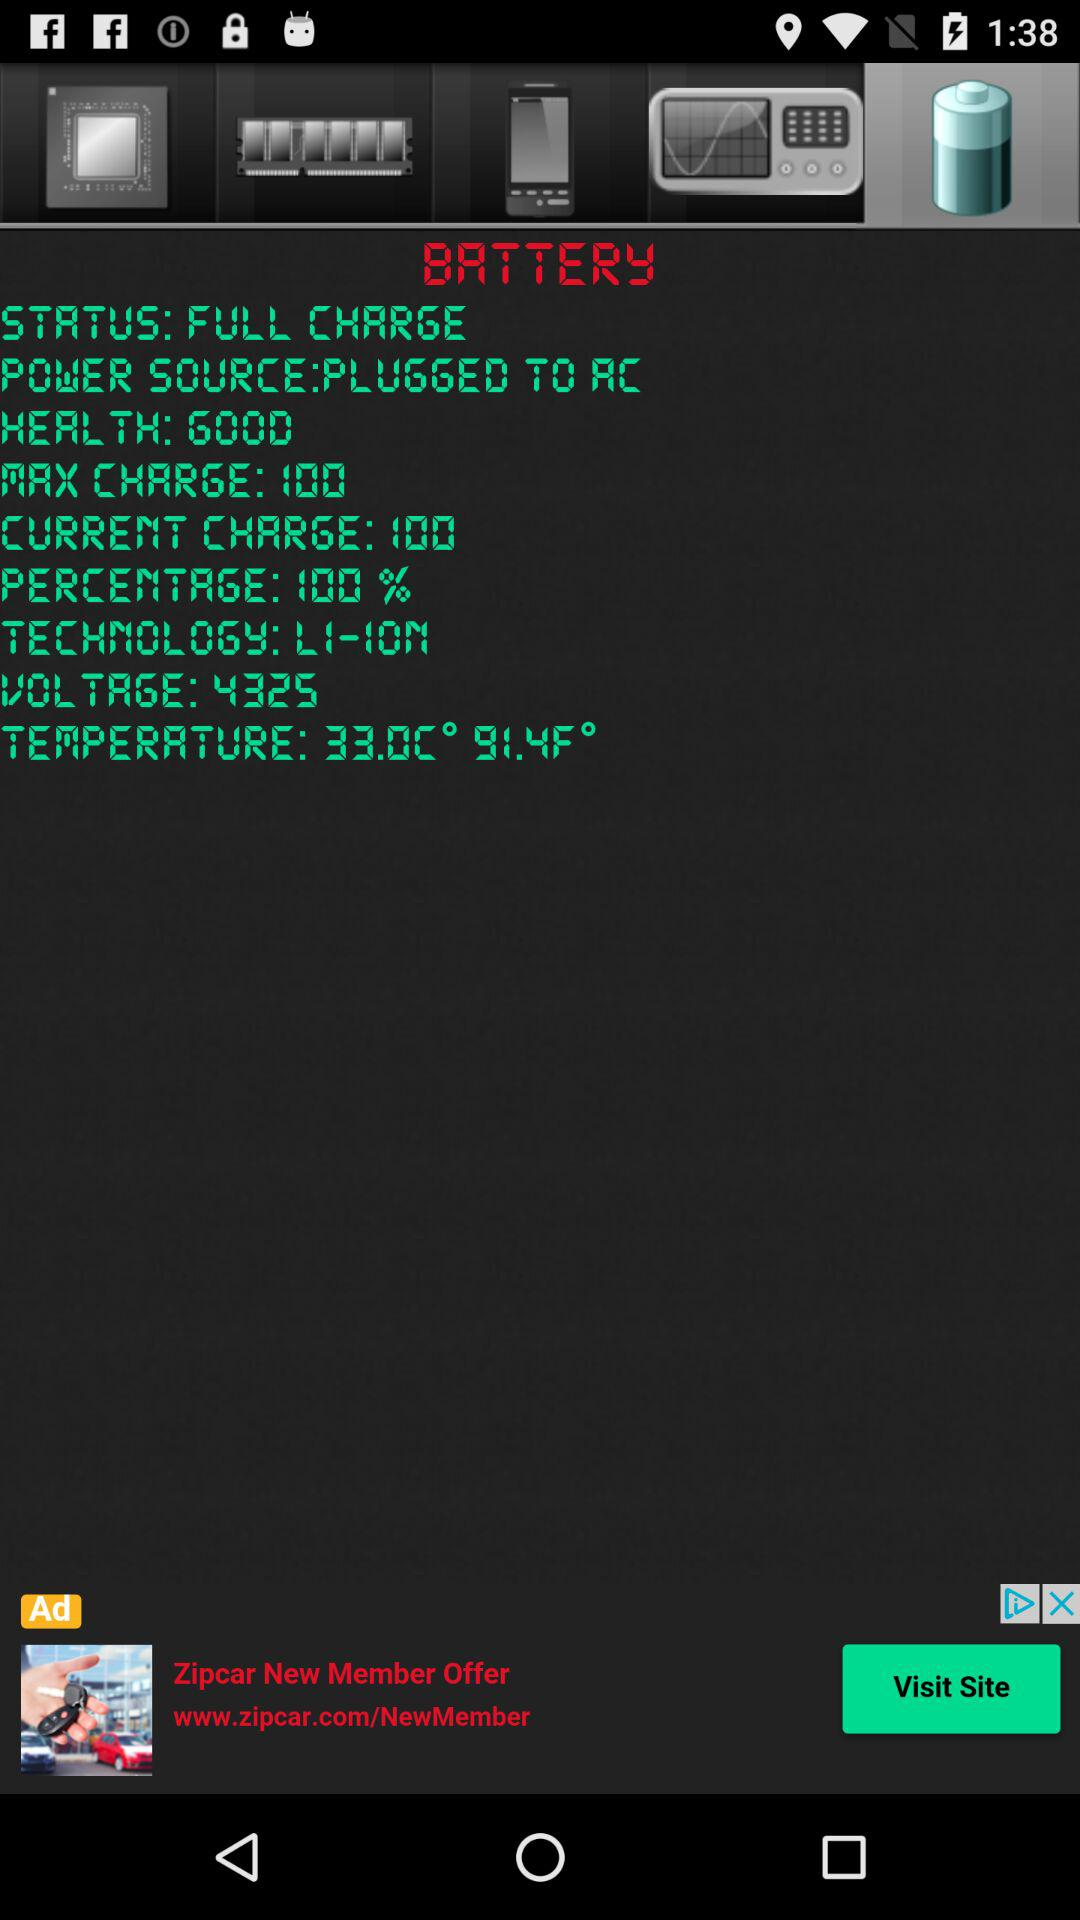What is the health? The health is good. 